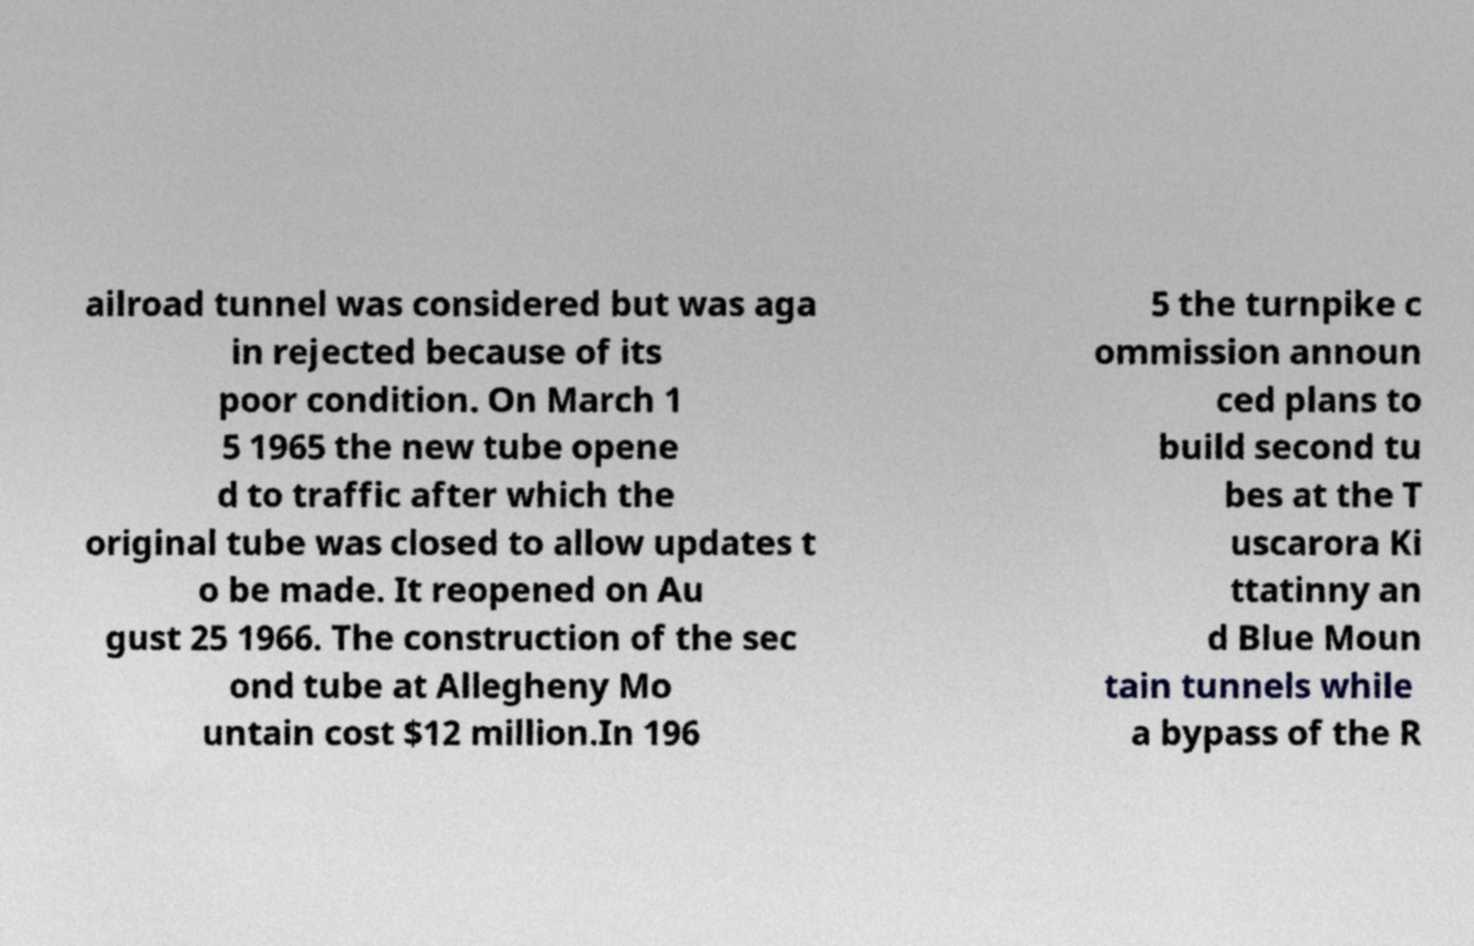Can you accurately transcribe the text from the provided image for me? ailroad tunnel was considered but was aga in rejected because of its poor condition. On March 1 5 1965 the new tube opene d to traffic after which the original tube was closed to allow updates t o be made. It reopened on Au gust 25 1966. The construction of the sec ond tube at Allegheny Mo untain cost $12 million.In 196 5 the turnpike c ommission announ ced plans to build second tu bes at the T uscarora Ki ttatinny an d Blue Moun tain tunnels while a bypass of the R 